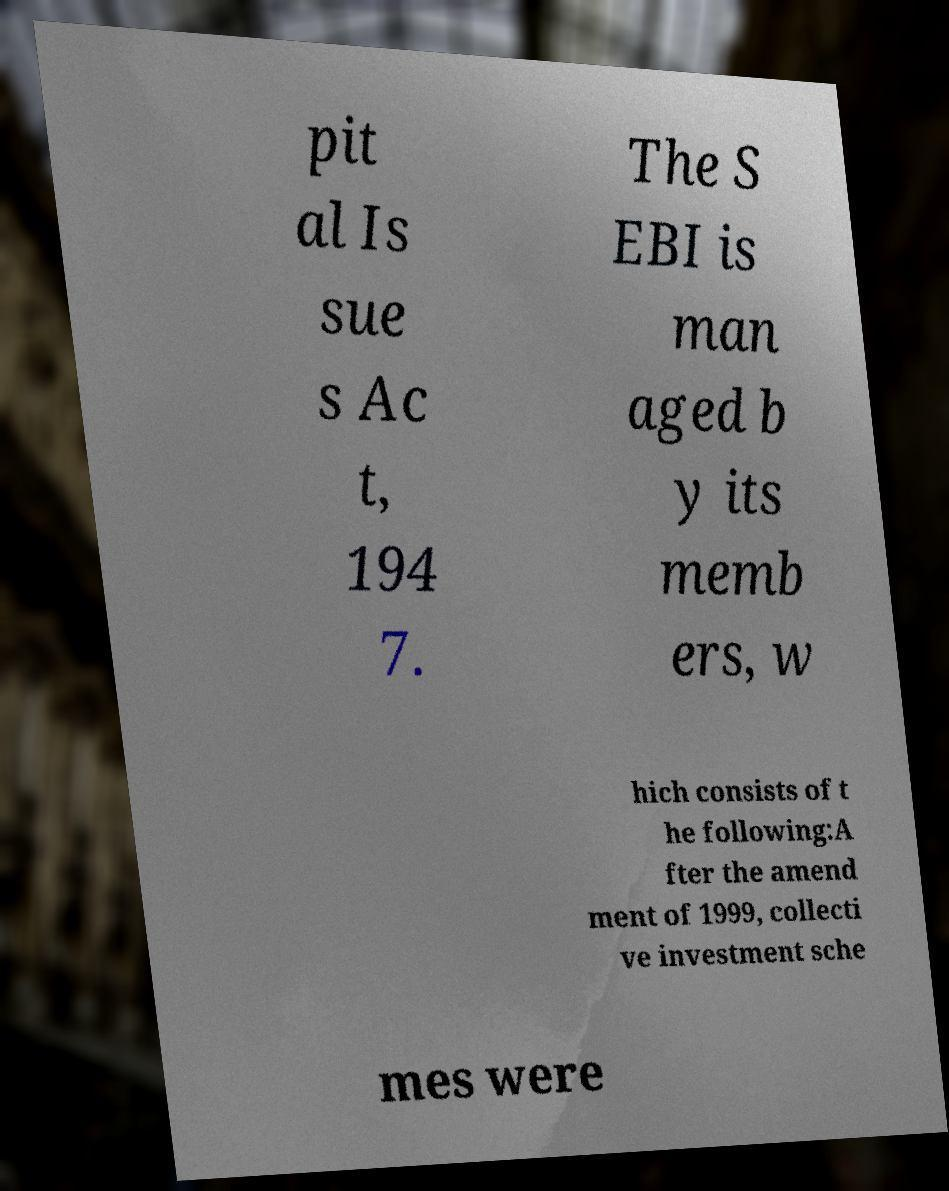What messages or text are displayed in this image? I need them in a readable, typed format. pit al Is sue s Ac t, 194 7. The S EBI is man aged b y its memb ers, w hich consists of t he following:A fter the amend ment of 1999, collecti ve investment sche mes were 